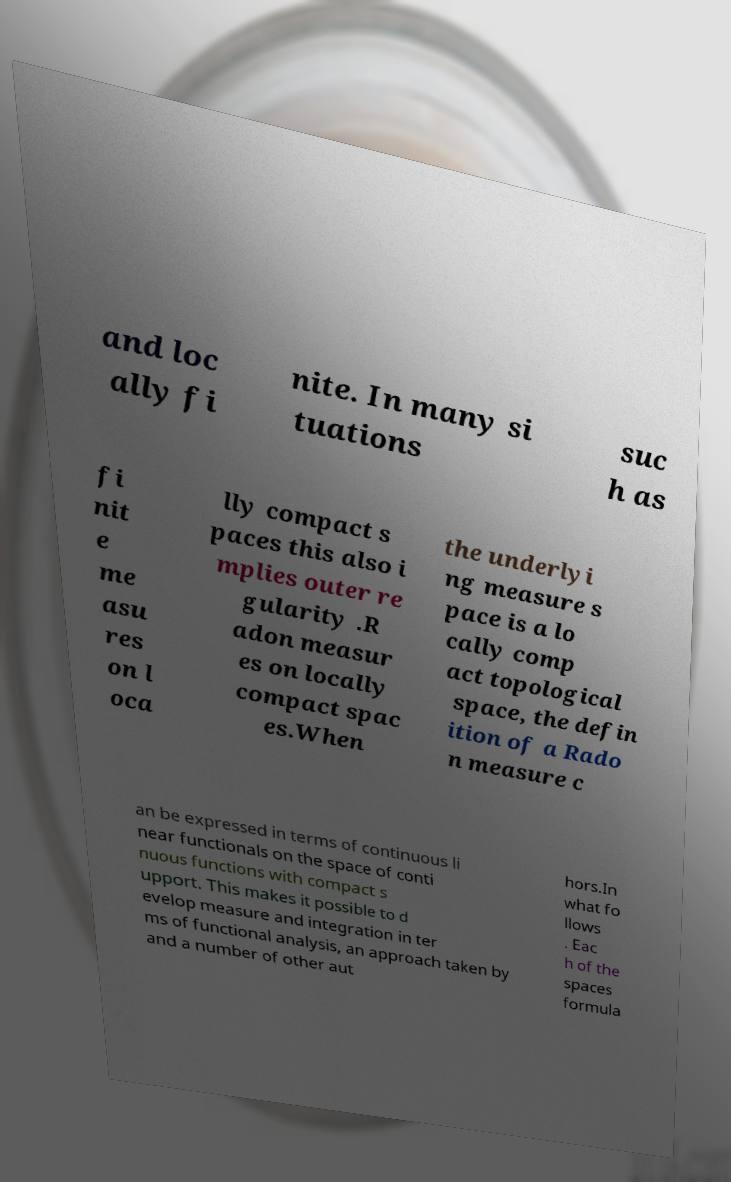What messages or text are displayed in this image? I need them in a readable, typed format. and loc ally fi nite. In many si tuations suc h as fi nit e me asu res on l oca lly compact s paces this also i mplies outer re gularity .R adon measur es on locally compact spac es.When the underlyi ng measure s pace is a lo cally comp act topological space, the defin ition of a Rado n measure c an be expressed in terms of continuous li near functionals on the space of conti nuous functions with compact s upport. This makes it possible to d evelop measure and integration in ter ms of functional analysis, an approach taken by and a number of other aut hors.In what fo llows . Eac h of the spaces formula 